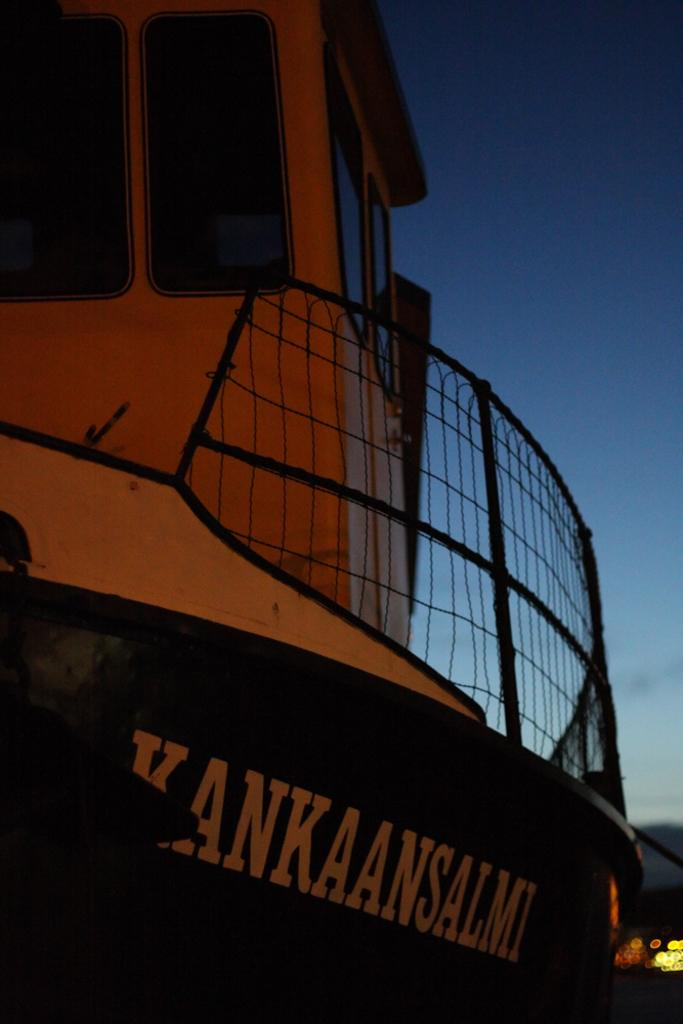What is the main subject of the image? There is a ship in the image. Can you describe the background of the ship? The background of the ship is blurred. What type of van is parked next to the ship in the image? There is no van present in the image; it only features a ship with a blurred background. 